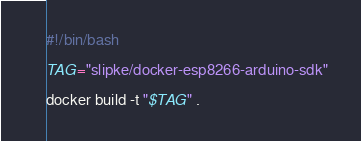Convert code to text. <code><loc_0><loc_0><loc_500><loc_500><_Bash_>#!/bin/bash

TAG="slipke/docker-esp8266-arduino-sdk"

docker build -t "$TAG" .
</code> 